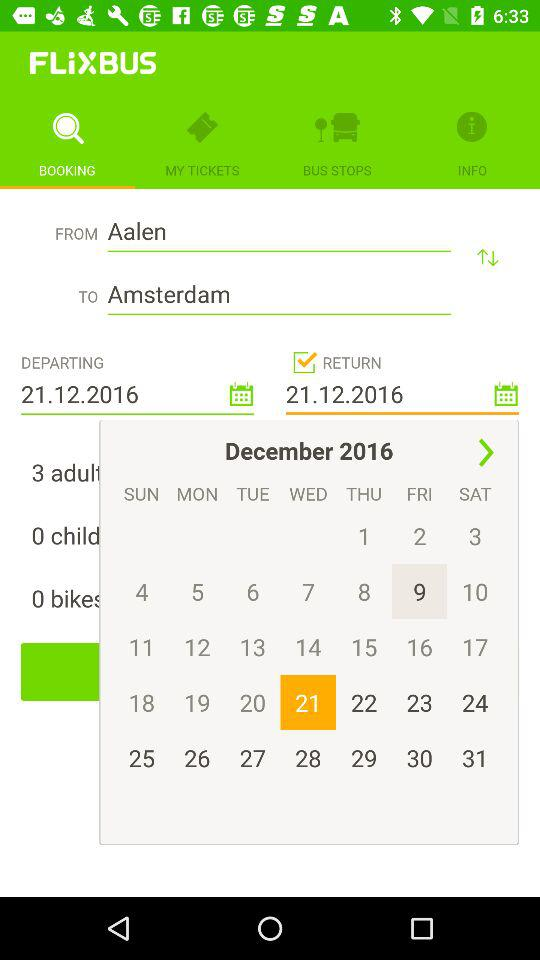How many days are between the departure and return dates?
Answer the question using a single word or phrase. 0 